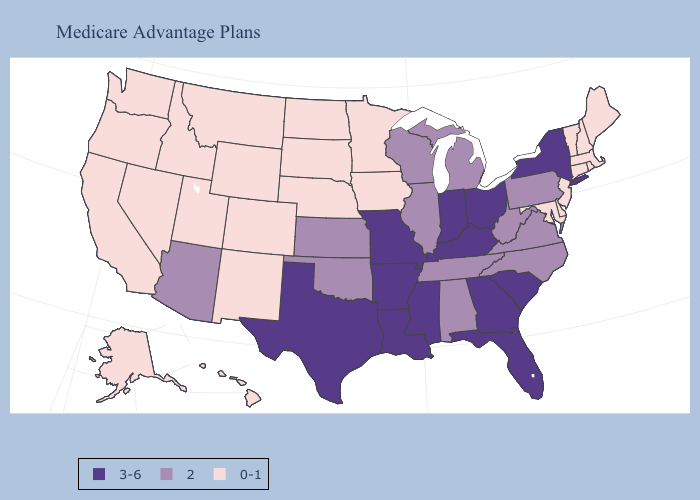Which states hav the highest value in the West?
Give a very brief answer. Arizona. What is the lowest value in the South?
Write a very short answer. 0-1. Does Arizona have the lowest value in the West?
Keep it brief. No. Among the states that border Mississippi , which have the lowest value?
Give a very brief answer. Alabama, Tennessee. Name the states that have a value in the range 2?
Write a very short answer. Alabama, Arizona, Illinois, Kansas, Michigan, North Carolina, Oklahoma, Pennsylvania, Tennessee, Virginia, Wisconsin, West Virginia. Name the states that have a value in the range 2?
Quick response, please. Alabama, Arizona, Illinois, Kansas, Michigan, North Carolina, Oklahoma, Pennsylvania, Tennessee, Virginia, Wisconsin, West Virginia. What is the highest value in states that border Mississippi?
Give a very brief answer. 3-6. Which states have the lowest value in the USA?
Short answer required. Alaska, California, Colorado, Connecticut, Delaware, Hawaii, Iowa, Idaho, Massachusetts, Maryland, Maine, Minnesota, Montana, North Dakota, Nebraska, New Hampshire, New Jersey, New Mexico, Nevada, Oregon, Rhode Island, South Dakota, Utah, Vermont, Washington, Wyoming. Among the states that border Florida , does Georgia have the lowest value?
Answer briefly. No. Does Texas have the same value as Rhode Island?
Write a very short answer. No. Does the map have missing data?
Quick response, please. No. What is the value of Nebraska?
Quick response, please. 0-1. Does the first symbol in the legend represent the smallest category?
Give a very brief answer. No. What is the value of Kansas?
Give a very brief answer. 2. What is the highest value in states that border South Carolina?
Keep it brief. 3-6. 